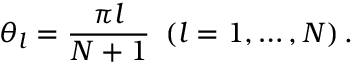<formula> <loc_0><loc_0><loc_500><loc_500>\theta _ { l } = \frac { \pi l } { N + 1 } \left ( l = 1 , \dots , N \right ) .</formula> 